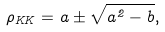Convert formula to latex. <formula><loc_0><loc_0><loc_500><loc_500>\rho _ { K K } = a \pm \sqrt { a ^ { 2 } - b } ,</formula> 